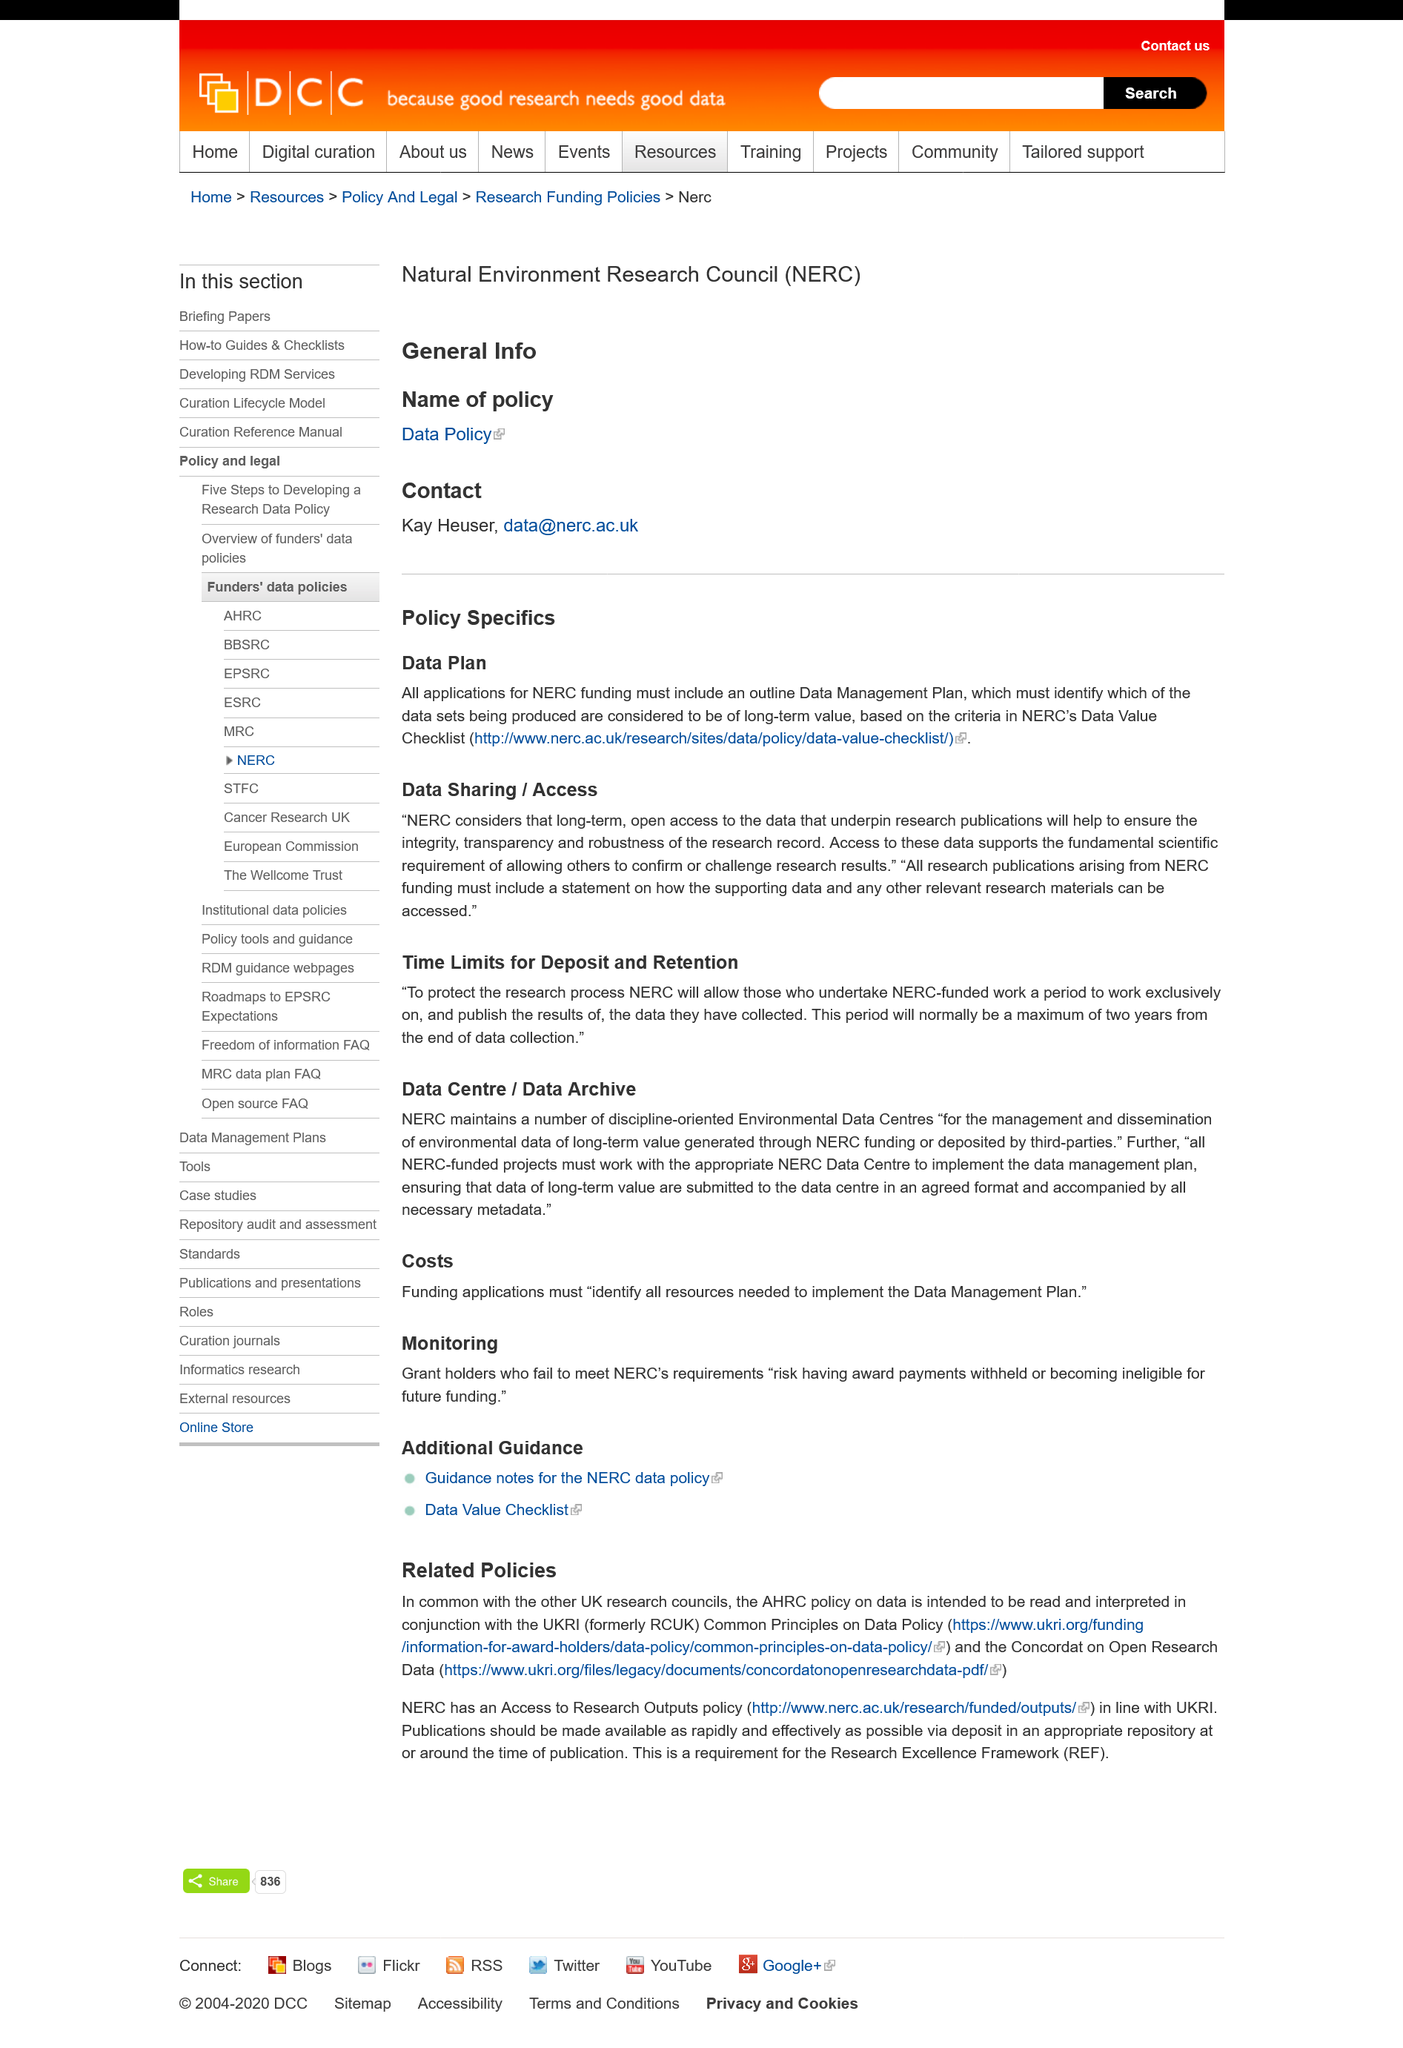Draw attention to some important aspects in this diagram. A Data Management Plan is required for all applications seeking funding from the NERC. For NERC-funded research, there is a two-year time limit to publish the results of the data collected, starting from the end of data collection. 